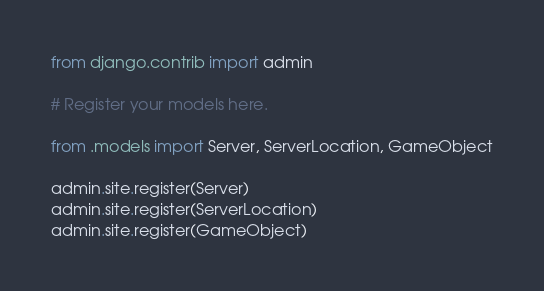<code> <loc_0><loc_0><loc_500><loc_500><_Python_>from django.contrib import admin

# Register your models here.

from .models import Server, ServerLocation, GameObject

admin.site.register(Server)
admin.site.register(ServerLocation)
admin.site.register(GameObject)</code> 